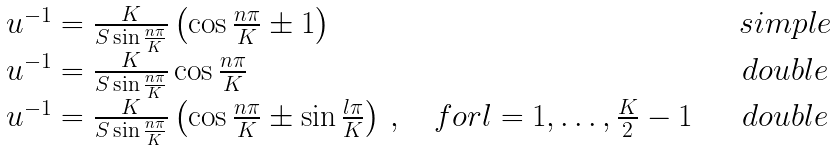<formula> <loc_0><loc_0><loc_500><loc_500>\begin{array} { l c } u ^ { - 1 } = \frac { K } { S \sin \frac { n \pi } { K } } \left ( \cos \frac { n \pi } { K } \pm 1 \right ) & \quad s i m p l e \\ u ^ { - 1 } = \frac { K } { S \sin \frac { n \pi } { K } } \cos \frac { n \pi } { K } & \quad d o u b l e \\ u ^ { - 1 } = \frac { K } { S \sin \frac { n \pi } { K } } \left ( \cos \frac { n \pi } { K } \pm \sin \frac { l \pi } { K } \right ) \, , \quad f o r l = 1 , \dots , \frac { K } { 2 } - 1 & \quad d o u b l e \end{array}</formula> 